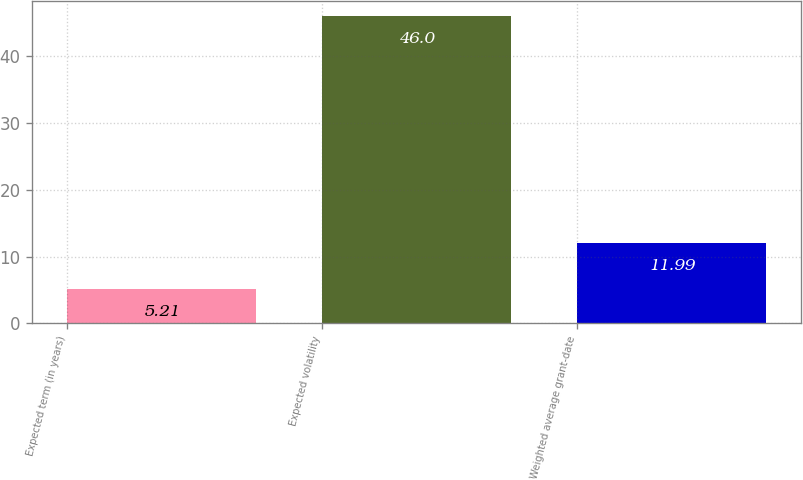Convert chart to OTSL. <chart><loc_0><loc_0><loc_500><loc_500><bar_chart><fcel>Expected term (in years)<fcel>Expected volatility<fcel>Weighted average grant-date<nl><fcel>5.21<fcel>46<fcel>11.99<nl></chart> 